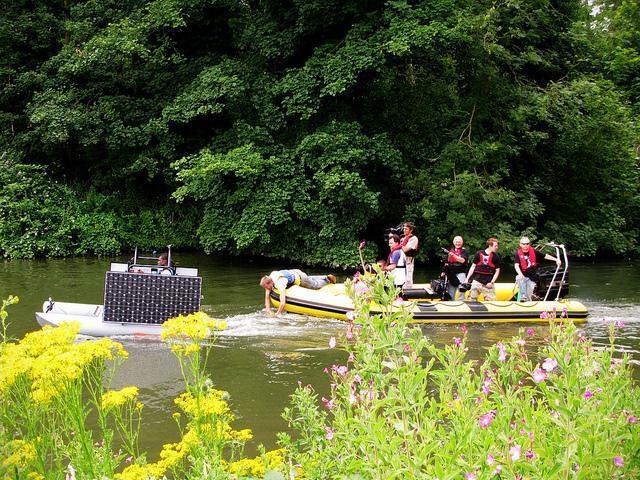How many people are on the boat?
Give a very brief answer. 5. How many boats are there?
Give a very brief answer. 2. How many bears are standing near the waterfalls?
Give a very brief answer. 0. 